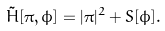Convert formula to latex. <formula><loc_0><loc_0><loc_500><loc_500>\tilde { H } [ \pi , \phi ] = | \pi | ^ { 2 } + S [ \phi ] .</formula> 